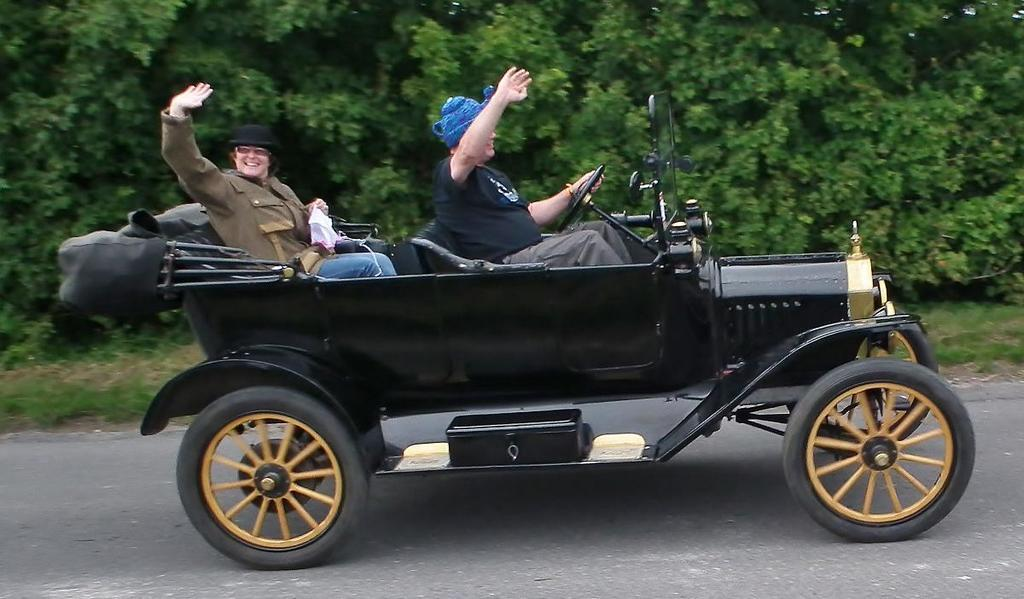How many people are in the vehicle in the image? There are two persons in the vehicle. What is the vehicle doing in the image? The vehicle is on a path. Can you describe the expression of one of the persons? One person is smiling. What can be seen in the background of the image? There is a lot of greenery in the background. How does the vehicle control the ground in the image? The vehicle does not control the ground in the image; it is simply driving on a path. What type of pull can be seen in the image? There is no pull visible in the image. 